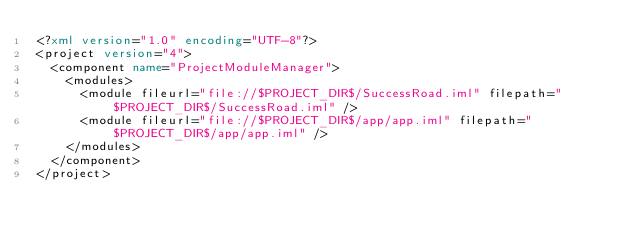Convert code to text. <code><loc_0><loc_0><loc_500><loc_500><_XML_><?xml version="1.0" encoding="UTF-8"?>
<project version="4">
  <component name="ProjectModuleManager">
    <modules>
      <module fileurl="file://$PROJECT_DIR$/SuccessRoad.iml" filepath="$PROJECT_DIR$/SuccessRoad.iml" />
      <module fileurl="file://$PROJECT_DIR$/app/app.iml" filepath="$PROJECT_DIR$/app/app.iml" />
    </modules>
  </component>
</project></code> 